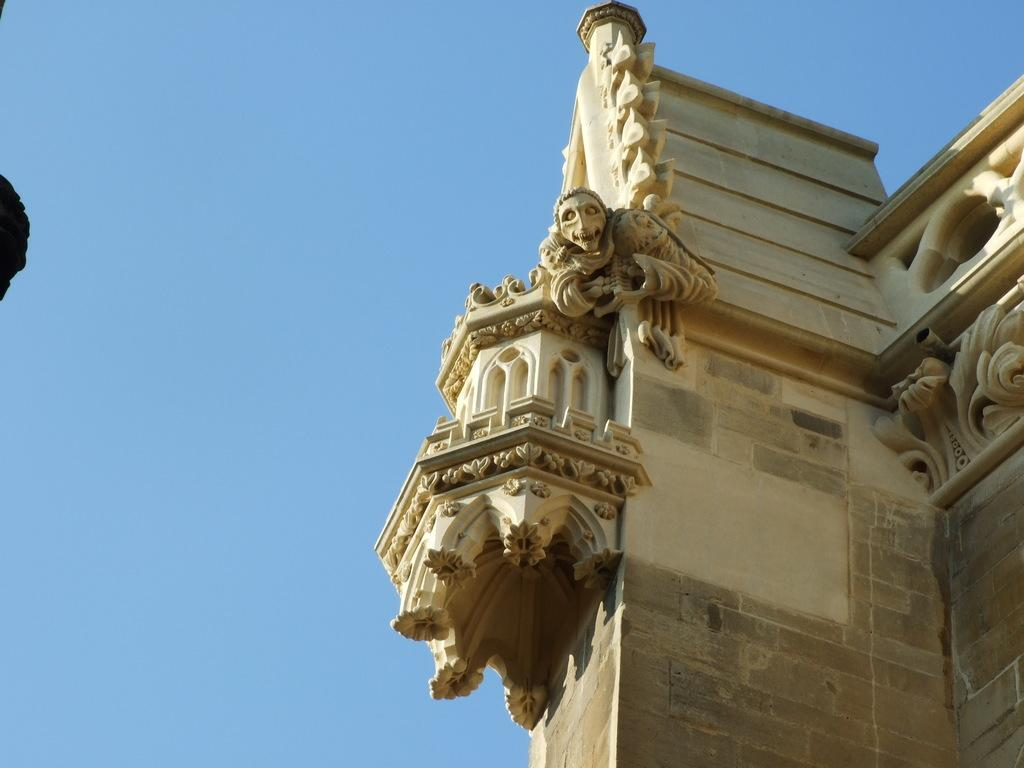What is the main structure visible in the image? There is a building in the image. Are there any additional features on the building? Yes, there is a sculpture on the building. What can be seen in the background of the image? The sky is visible in the background of the image. How many snakes are coiled around the sculpture on the building? There are no snakes present in the image; the sculpture does not depict any snakes. What type of bell can be heard ringing in the image? There is no bell present in the image, and therefore no sound can be heard. 